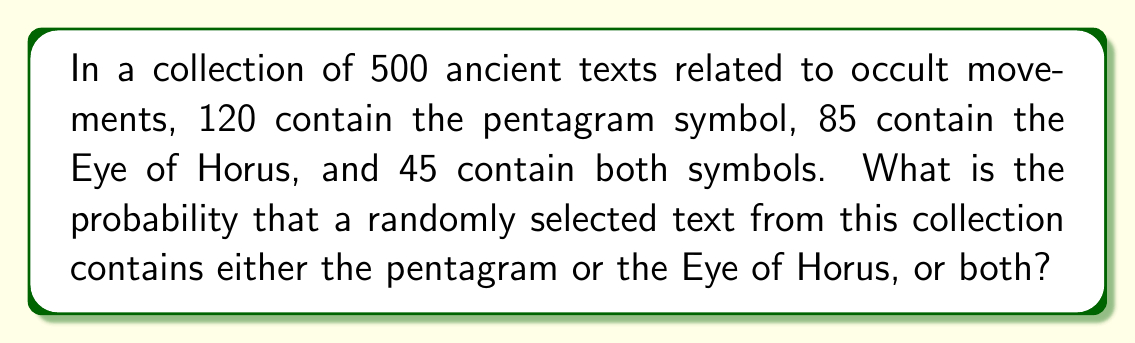Can you answer this question? Let's approach this step-by-step using set theory and probability:

1) Let P be the event of a text containing a pentagram, and H be the event of a text containing the Eye of Horus.

2) We're given:
   - Total number of texts: n(U) = 500
   - Texts with pentagram: n(P) = 120
   - Texts with Eye of Horus: n(H) = 85
   - Texts with both symbols: n(P ∩ H) = 45

3) We need to find P(P ∪ H), the probability of a text containing either symbol or both.

4) Using the addition rule of probability:
   P(P ∪ H) = P(P) + P(H) - P(P ∩ H)

5) Calculate each probability:
   P(P) = n(P) / n(U) = 120 / 500 = 0.24
   P(H) = n(H) / n(U) = 85 / 500 = 0.17
   P(P ∩ H) = n(P ∩ H) / n(U) = 45 / 500 = 0.09

6) Substitute these values into the formula:
   P(P ∪ H) = 0.24 + 0.17 - 0.09 = 0.32

7) Therefore, the probability is 0.32 or 32%.
Answer: 0.32 